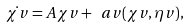Convert formula to latex. <formula><loc_0><loc_0><loc_500><loc_500>\dot { \chi v } = A \chi v + \ a v ( \chi v , \eta v ) ,</formula> 